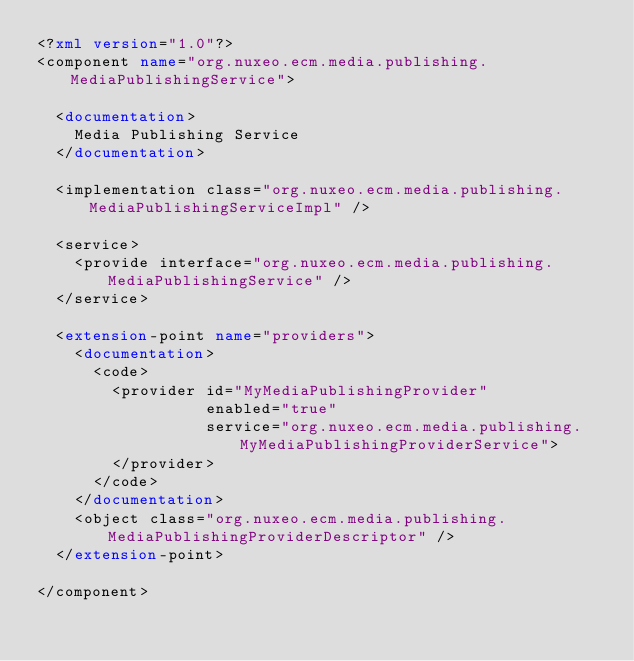Convert code to text. <code><loc_0><loc_0><loc_500><loc_500><_XML_><?xml version="1.0"?>
<component name="org.nuxeo.ecm.media.publishing.MediaPublishingService">

  <documentation>
    Media Publishing Service
  </documentation>

  <implementation class="org.nuxeo.ecm.media.publishing.MediaPublishingServiceImpl" />

  <service>
    <provide interface="org.nuxeo.ecm.media.publishing.MediaPublishingService" />
  </service>

  <extension-point name="providers">
    <documentation>
      <code>
        <provider id="MyMediaPublishingProvider"
                  enabled="true"
                  service="org.nuxeo.ecm.media.publishing.MyMediaPublishingProviderService">
        </provider>
      </code>
    </documentation>
    <object class="org.nuxeo.ecm.media.publishing.MediaPublishingProviderDescriptor" />
  </extension-point>

</component></code> 